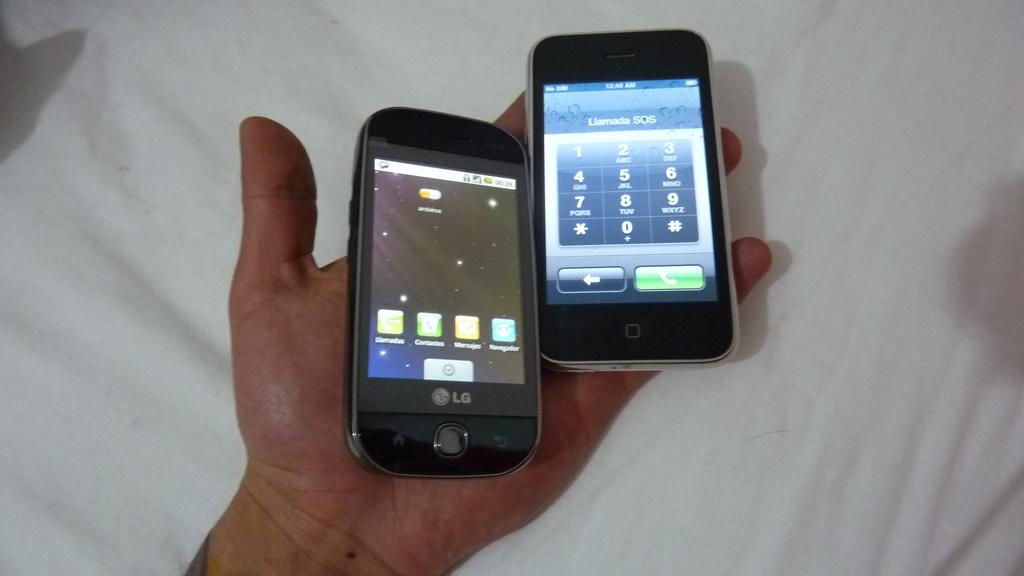What brand is the cell in the palm area of the hand?
Offer a terse response. Lg. What word proceeds "sos"?
Your answer should be compact. Llamada. 